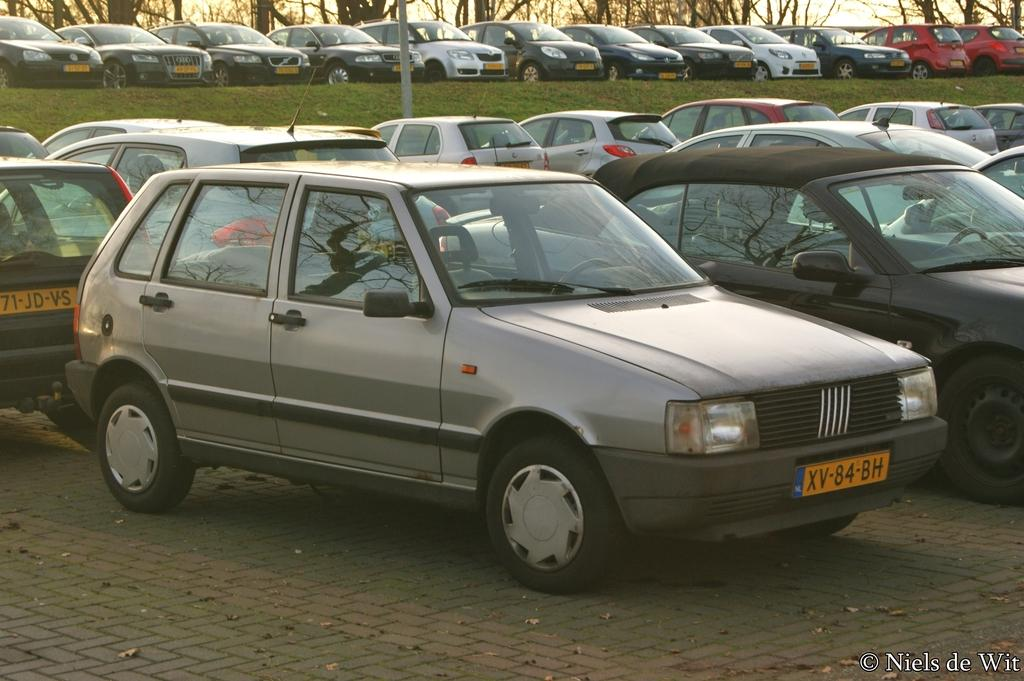What can be seen in the image that is used for transportation? There are motor vehicles parked in rows in the image. What type of natural elements can be seen in the background of the image? There are trees and the sky visible in the background of the image. What is present on the floor in the image? Shredded leaves are present on the floor in the image. What theory is being discussed in the image? There is no discussion or theory present in the image; it primarily features motor vehicles parked in rows. 